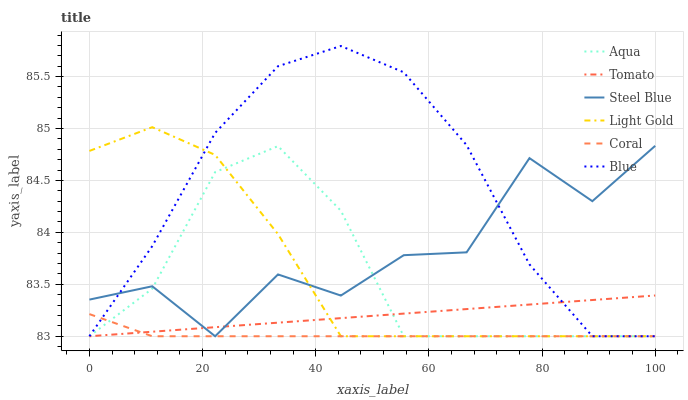Does Coral have the minimum area under the curve?
Answer yes or no. Yes. Does Blue have the maximum area under the curve?
Answer yes or no. Yes. Does Blue have the minimum area under the curve?
Answer yes or no. No. Does Coral have the maximum area under the curve?
Answer yes or no. No. Is Tomato the smoothest?
Answer yes or no. Yes. Is Steel Blue the roughest?
Answer yes or no. Yes. Is Blue the smoothest?
Answer yes or no. No. Is Blue the roughest?
Answer yes or no. No. Does Tomato have the lowest value?
Answer yes or no. Yes. Does Blue have the highest value?
Answer yes or no. Yes. Does Coral have the highest value?
Answer yes or no. No. Does Light Gold intersect Tomato?
Answer yes or no. Yes. Is Light Gold less than Tomato?
Answer yes or no. No. Is Light Gold greater than Tomato?
Answer yes or no. No. 